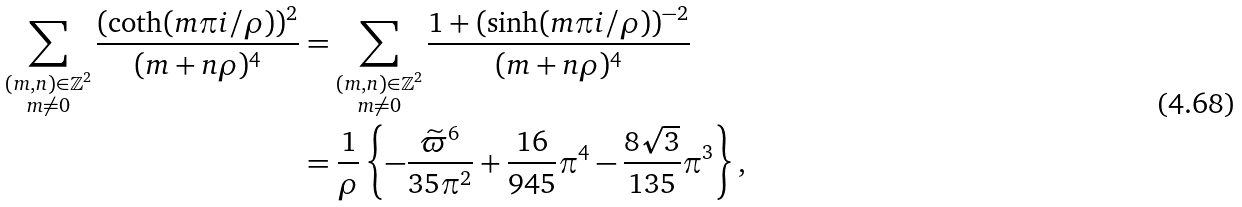<formula> <loc_0><loc_0><loc_500><loc_500>\sum _ { \substack { ( m , n ) \in \mathbb { Z } ^ { 2 } \\ m \neq 0 } } \frac { ( \coth ( m \pi i / \rho ) ) ^ { 2 } } { ( m + n \rho ) ^ { 4 } } & = \sum _ { \substack { ( m , n ) \in \mathbb { Z } ^ { 2 } \\ m \neq 0 } } \frac { 1 + ( \sinh ( m \pi i / \rho ) ) ^ { - 2 } } { ( m + n \rho ) ^ { 4 } } \\ & = \frac { 1 } { \rho } \left \{ - \frac { \widetilde { \varpi } ^ { 6 } } { 3 5 \pi ^ { 2 } } + \frac { 1 6 } { 9 4 5 } \pi ^ { 4 } - \frac { 8 \sqrt { 3 } } { 1 3 5 } \pi ^ { 3 } \right \} ,</formula> 